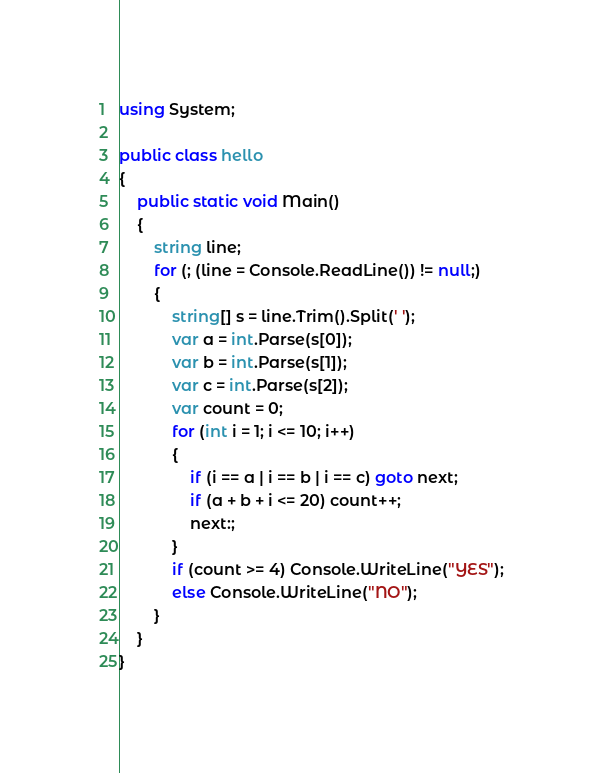<code> <loc_0><loc_0><loc_500><loc_500><_C#_>using System;

public class hello
{
    public static void Main()
    {
        string line;
        for (; (line = Console.ReadLine()) != null;)
        {
            string[] s = line.Trim().Split(' ');
            var a = int.Parse(s[0]);
            var b = int.Parse(s[1]);
            var c = int.Parse(s[2]);
            var count = 0;
            for (int i = 1; i <= 10; i++)
            {
                if (i == a | i == b | i == c) goto next;
                if (a + b + i <= 20) count++;
                next:;
            }
            if (count >= 4) Console.WriteLine("YES");
            else Console.WriteLine("NO");
        }
    }
}</code> 